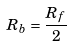<formula> <loc_0><loc_0><loc_500><loc_500>R _ { b } = \frac { R _ { f } } { 2 }</formula> 